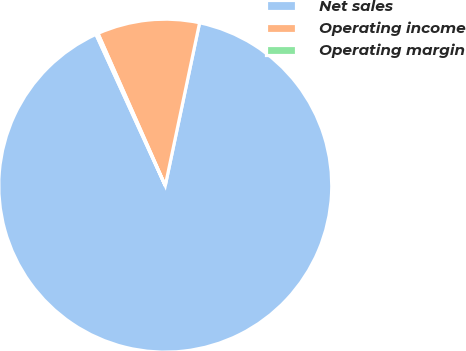Convert chart. <chart><loc_0><loc_0><loc_500><loc_500><pie_chart><fcel>Net sales<fcel>Operating income<fcel>Operating margin<nl><fcel>89.85%<fcel>9.93%<fcel>0.21%<nl></chart> 